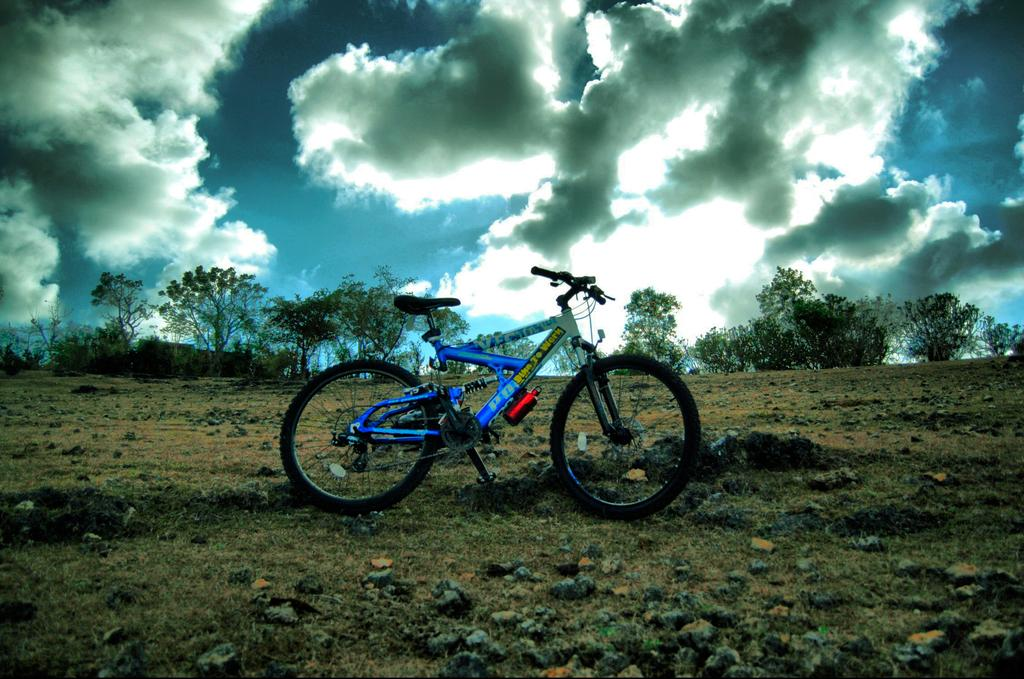What object is on the ground in the image? There is a bicycle on the ground in the image. What type of terrain is visible in the image? There are stones visible in the image. What can be seen in the background of the image? There are trees in the background of the image. What is the condition of the sky in the image? The sky is cloudy and visible at the top of the image. What type of meat is being grilled on the bicycle in the image? There is no meat or grill present in the image; it features a bicycle on the ground with stones and trees in the background. 